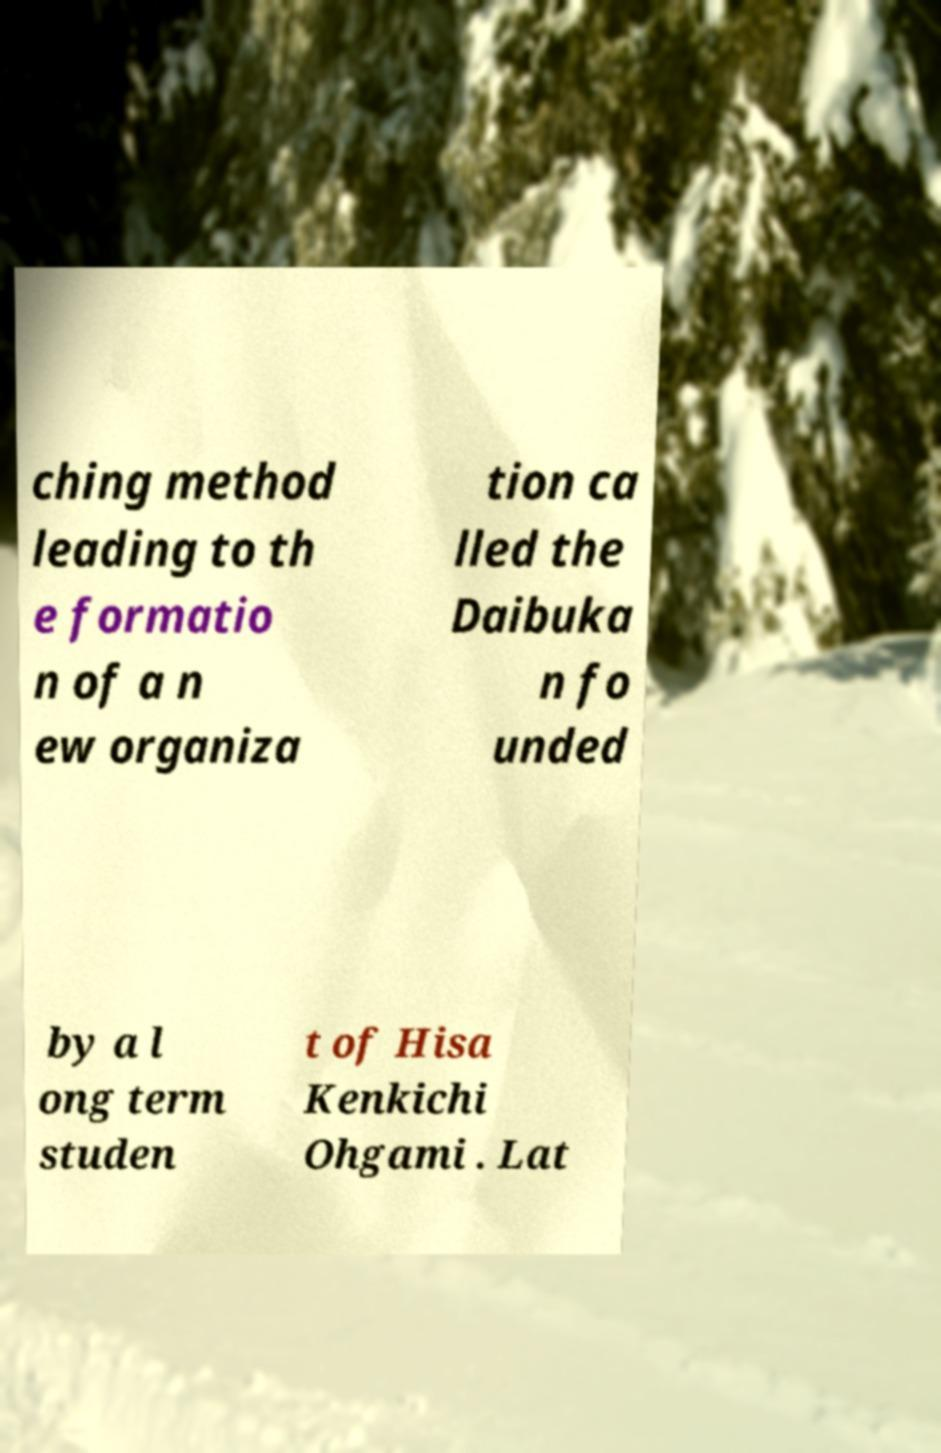Can you accurately transcribe the text from the provided image for me? ching method leading to th e formatio n of a n ew organiza tion ca lled the Daibuka n fo unded by a l ong term studen t of Hisa Kenkichi Ohgami . Lat 